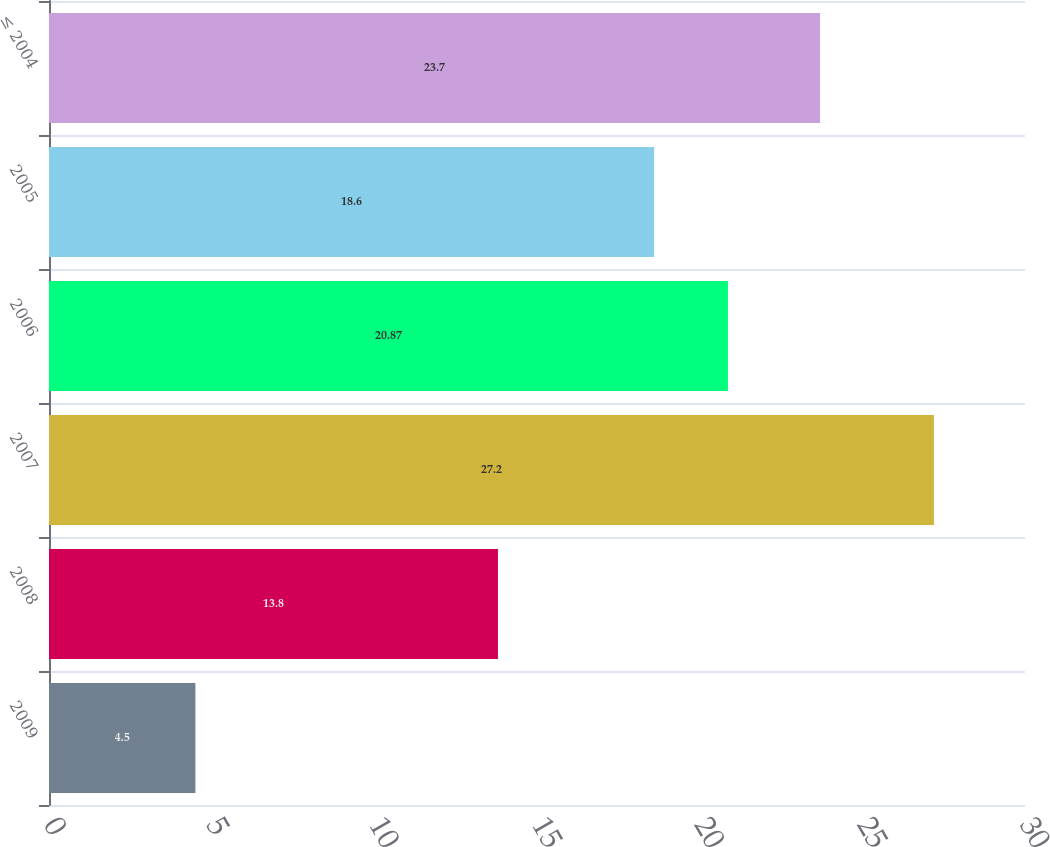Convert chart to OTSL. <chart><loc_0><loc_0><loc_500><loc_500><bar_chart><fcel>2009<fcel>2008<fcel>2007<fcel>2006<fcel>2005<fcel>≤ 2004<nl><fcel>4.5<fcel>13.8<fcel>27.2<fcel>20.87<fcel>18.6<fcel>23.7<nl></chart> 